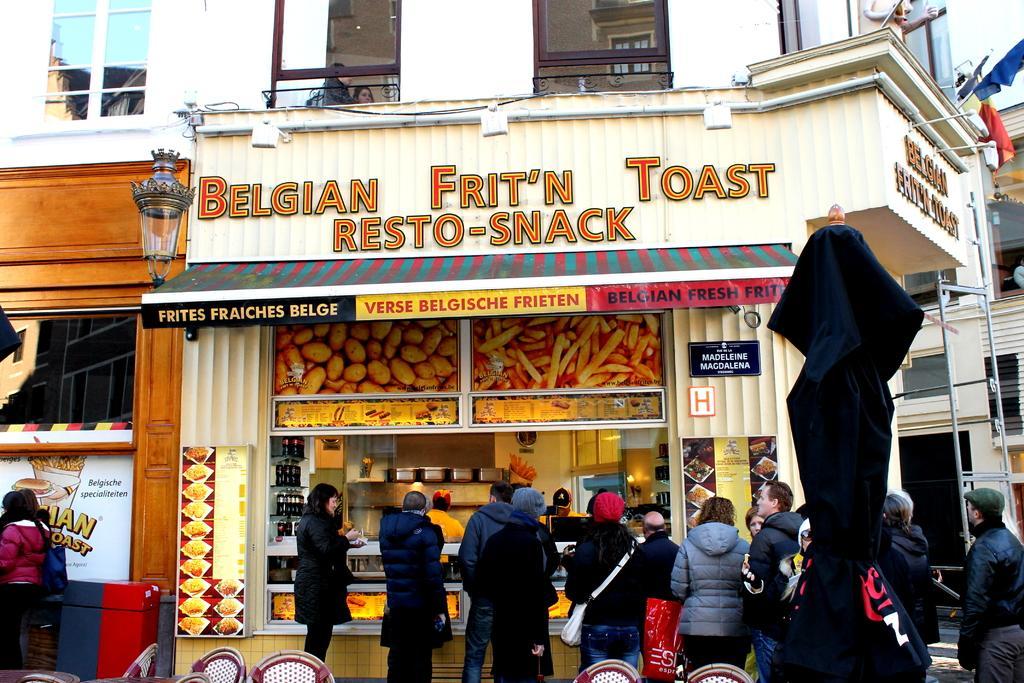In one or two sentences, can you explain what this image depicts? This image consists of a store. There are some persons standing at the bottom. There are flags on the right side. 